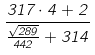Convert formula to latex. <formula><loc_0><loc_0><loc_500><loc_500>\frac { 3 1 7 \cdot 4 + 2 } { \frac { \sqrt { 2 8 9 } } { 4 4 2 } + 3 1 4 }</formula> 